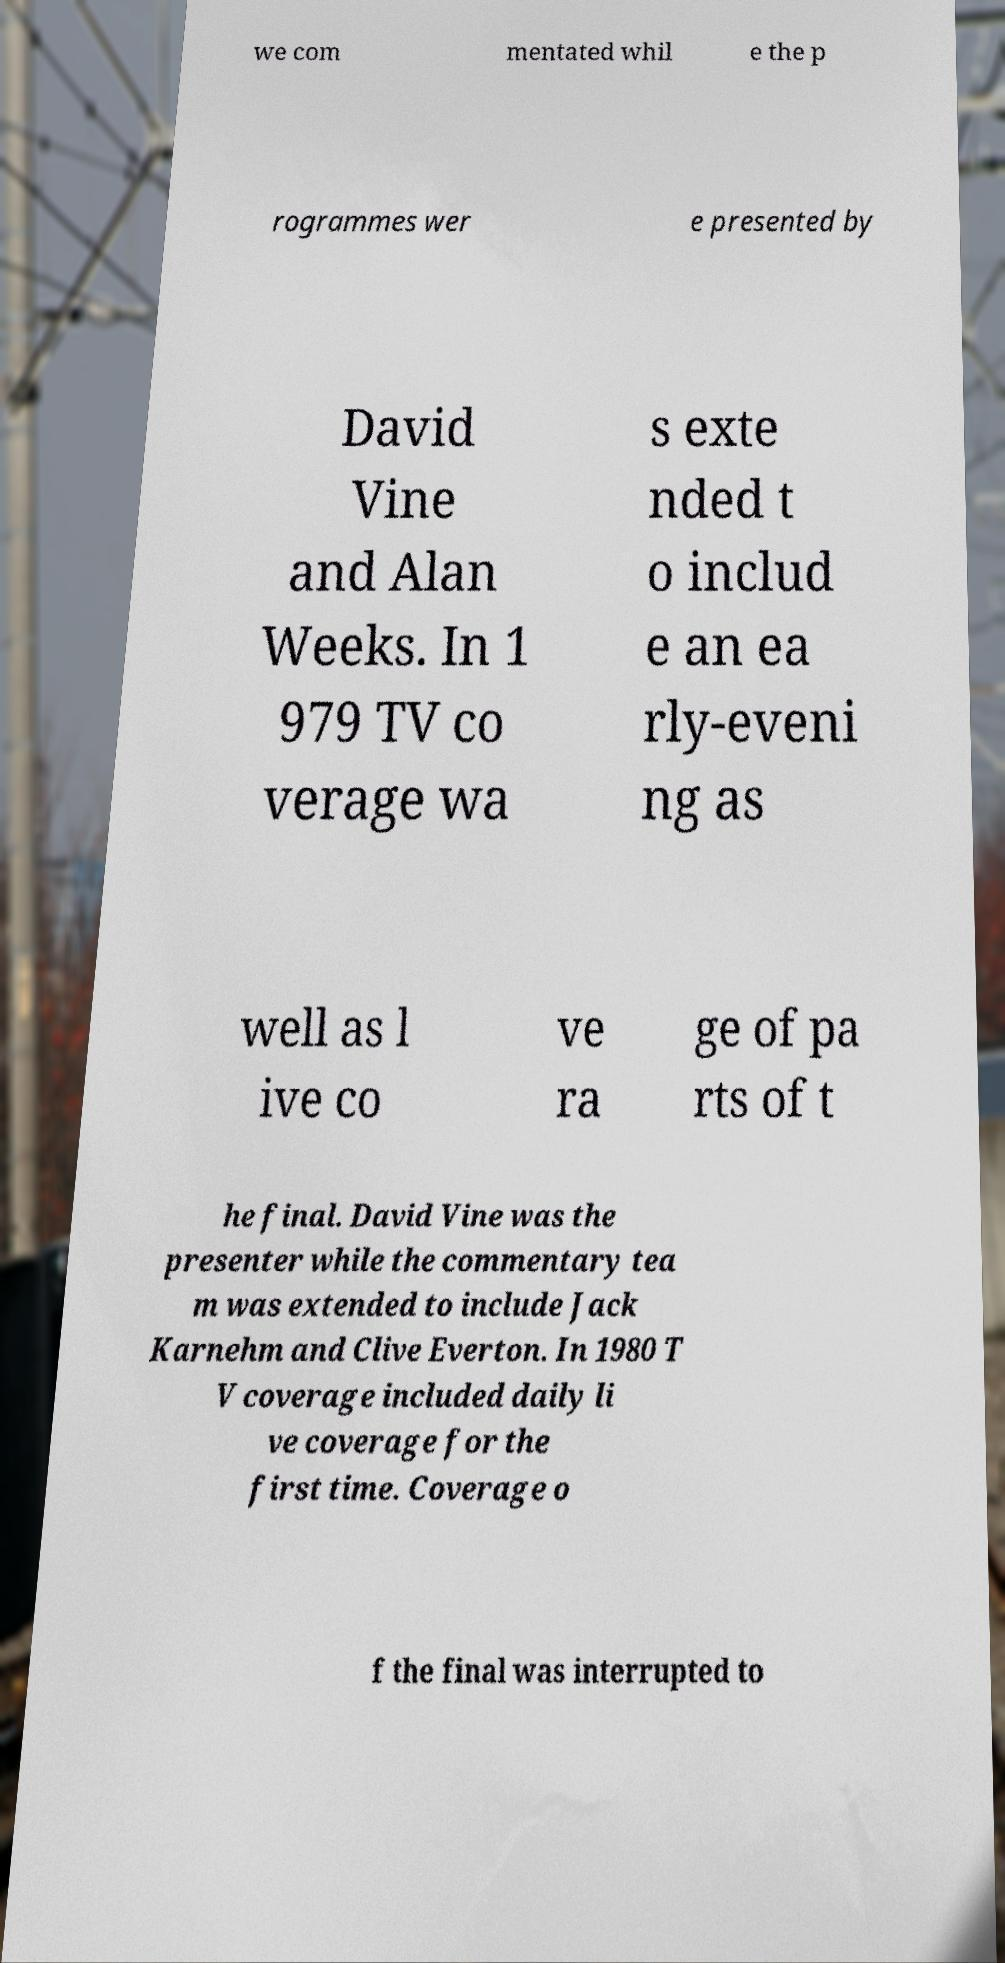There's text embedded in this image that I need extracted. Can you transcribe it verbatim? we com mentated whil e the p rogrammes wer e presented by David Vine and Alan Weeks. In 1 979 TV co verage wa s exte nded t o includ e an ea rly-eveni ng as well as l ive co ve ra ge of pa rts of t he final. David Vine was the presenter while the commentary tea m was extended to include Jack Karnehm and Clive Everton. In 1980 T V coverage included daily li ve coverage for the first time. Coverage o f the final was interrupted to 